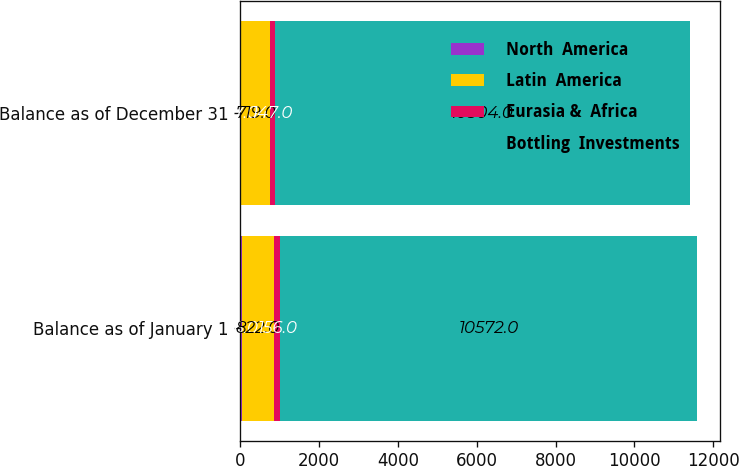Convert chart. <chart><loc_0><loc_0><loc_500><loc_500><stacked_bar_chart><ecel><fcel>Balance as of January 1<fcel>Balance as of December 31<nl><fcel>North  America<fcel>36<fcel>27<nl><fcel>Latin  America<fcel>822<fcel>719<nl><fcel>Eurasia &  Africa<fcel>156<fcel>147<nl><fcel>Bottling  Investments<fcel>10572<fcel>10504<nl></chart> 